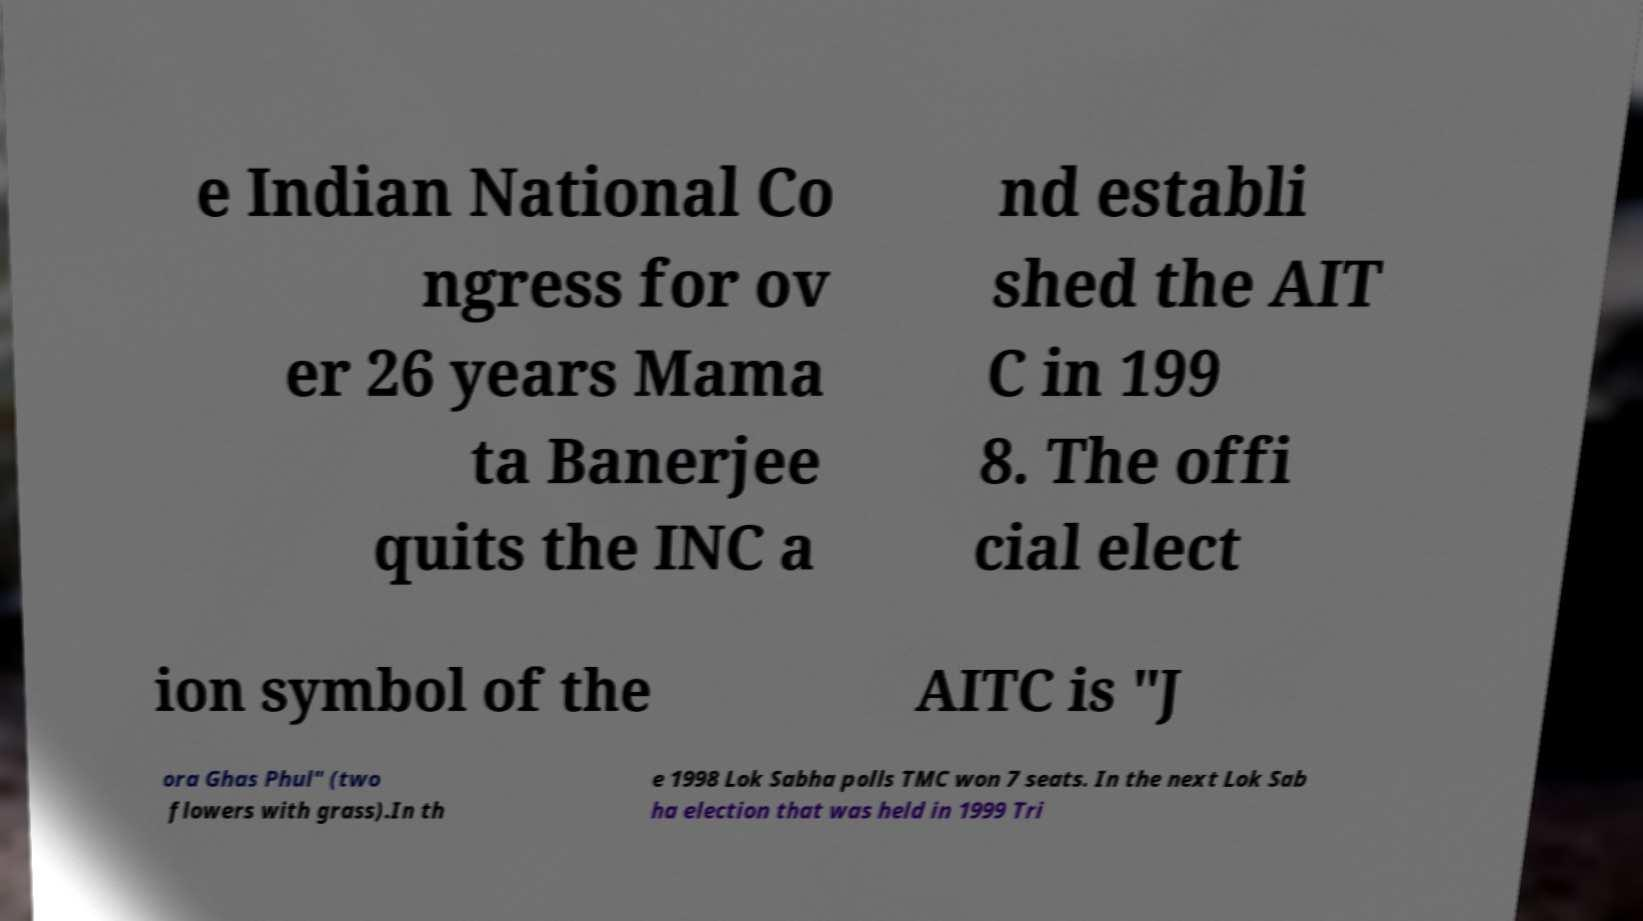Please identify and transcribe the text found in this image. e Indian National Co ngress for ov er 26 years Mama ta Banerjee quits the INC a nd establi shed the AIT C in 199 8. The offi cial elect ion symbol of the AITC is "J ora Ghas Phul" (two flowers with grass).In th e 1998 Lok Sabha polls TMC won 7 seats. In the next Lok Sab ha election that was held in 1999 Tri 